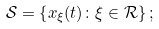<formula> <loc_0><loc_0><loc_500><loc_500>\mathcal { S } = \left \{ x _ { \xi } ( t ) \colon \xi \in \mathcal { R } \right \} ;</formula> 